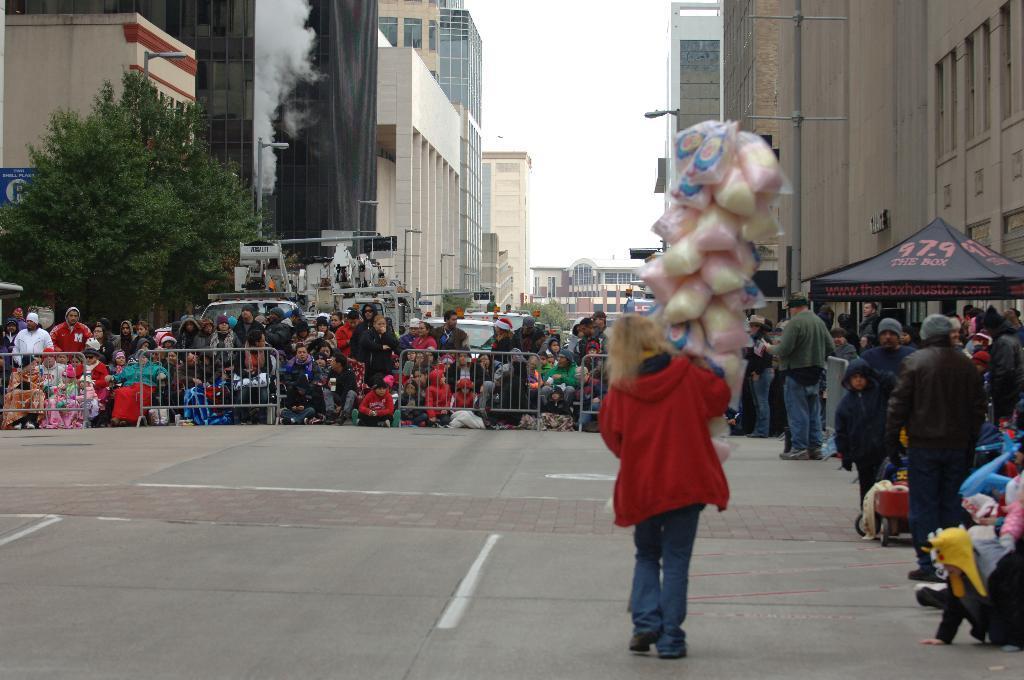Describe this image in one or two sentences. In the image we can see there is a person standing and she is holding a plastic packets in her hand. There are spectators watching and standing on the road. There are barricades and there are vehicles parked on the road. Behind there is a tree and there are buildings. There is a clear sky. 